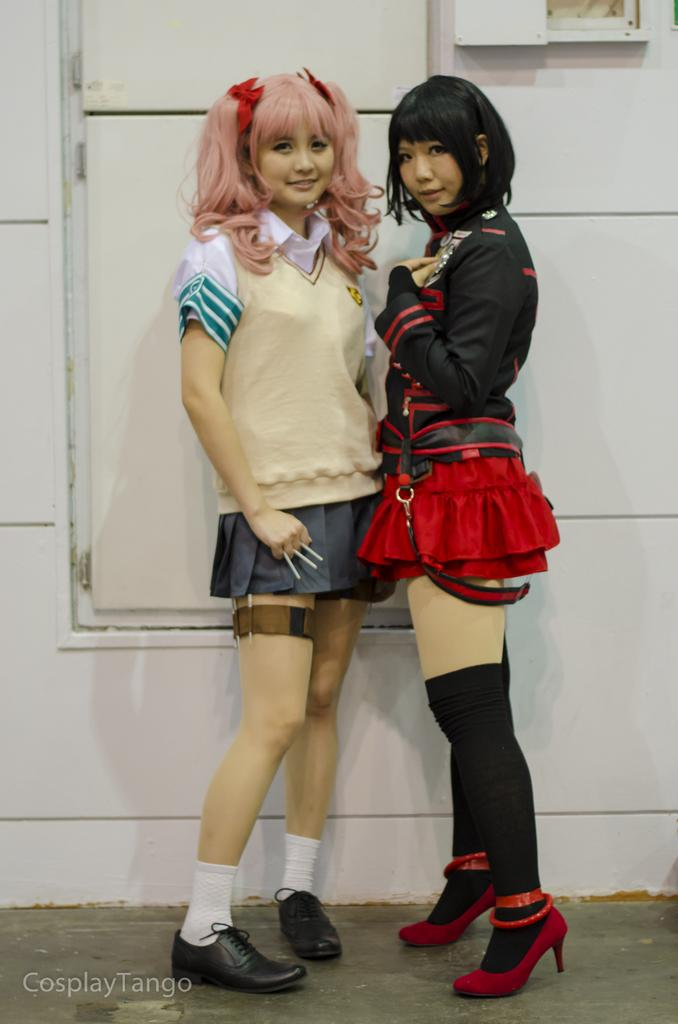How many people are in the image? There are two girls standing in the middle of the image. What can be seen in the bottom left-hand side of the image? There is a watermark in the bottom left-hand side of the image. Can you tell if the image has been altered or modified in any way? The image appears to be edited. What type of balance or scale is being used by the girls in the image? There is no balance or scale present in the image; the girls are simply standing in the middle of the image. Can you see any zippers on the girls' clothing in the image? There is no mention of zippers or any specific clothing details in the provided facts, so we cannot determine if there are any zippers present. 